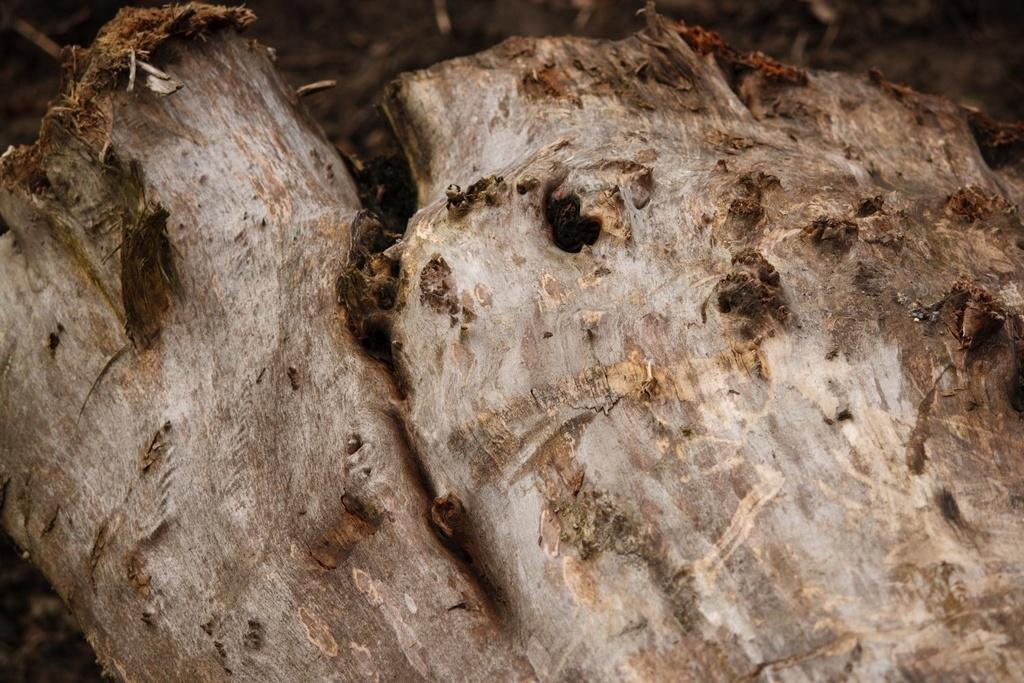What color is the tree trunk in the image? The tree trunk in the image is in brown and white color. How many people are in the crowd surrounding the tree trunk in the image? A: There is no crowd present in the image; it only features the tree trunk. 